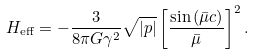<formula> <loc_0><loc_0><loc_500><loc_500>H _ { \text {eff} } = - \frac { 3 } { 8 \pi G \gamma ^ { 2 } } \sqrt { | p | } \left [ \frac { \sin \left ( \bar { \mu } c \right ) } { \bar { \mu } } \right ] ^ { 2 } .</formula> 